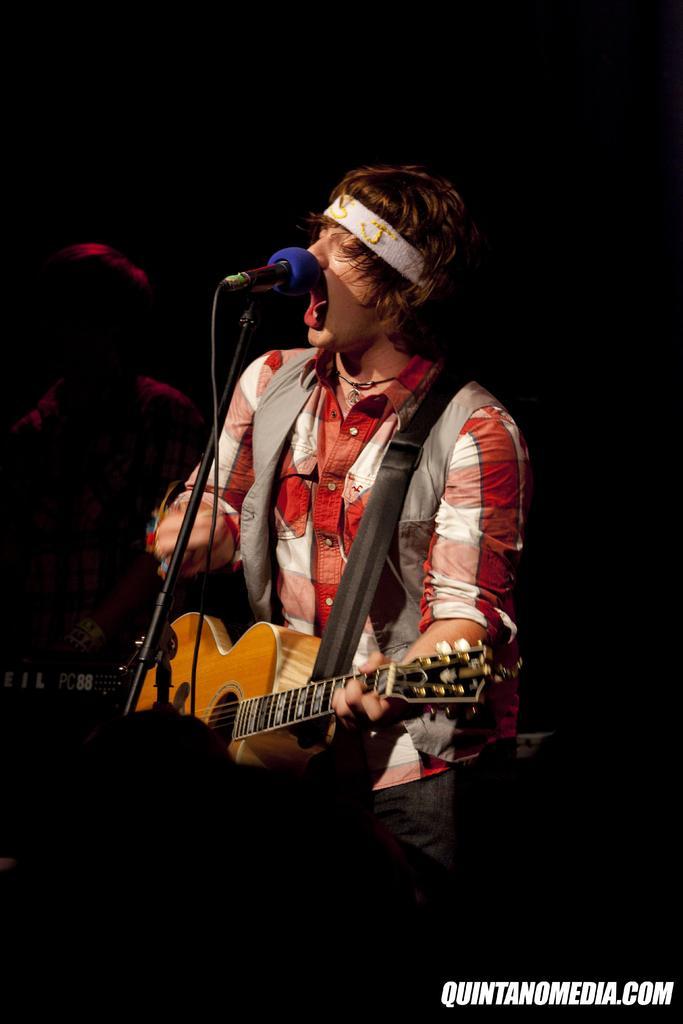Describe this image in one or two sentences. There is a man singing on mic and playing a guitar and the background is whole dark. 